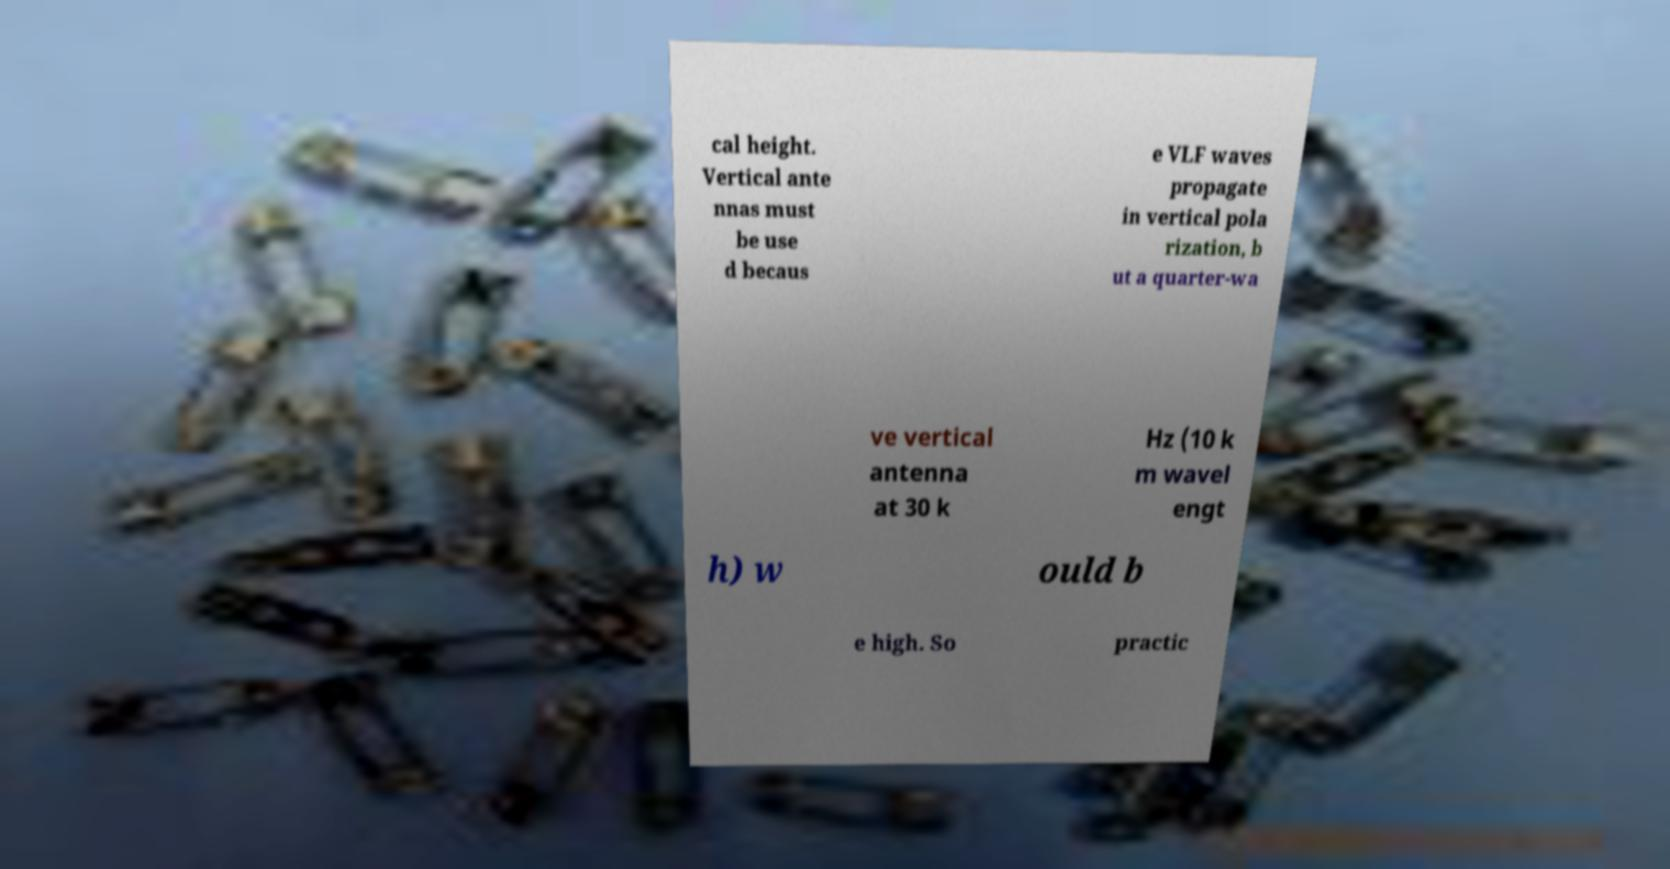There's text embedded in this image that I need extracted. Can you transcribe it verbatim? cal height. Vertical ante nnas must be use d becaus e VLF waves propagate in vertical pola rization, b ut a quarter-wa ve vertical antenna at 30 k Hz (10 k m wavel engt h) w ould b e high. So practic 